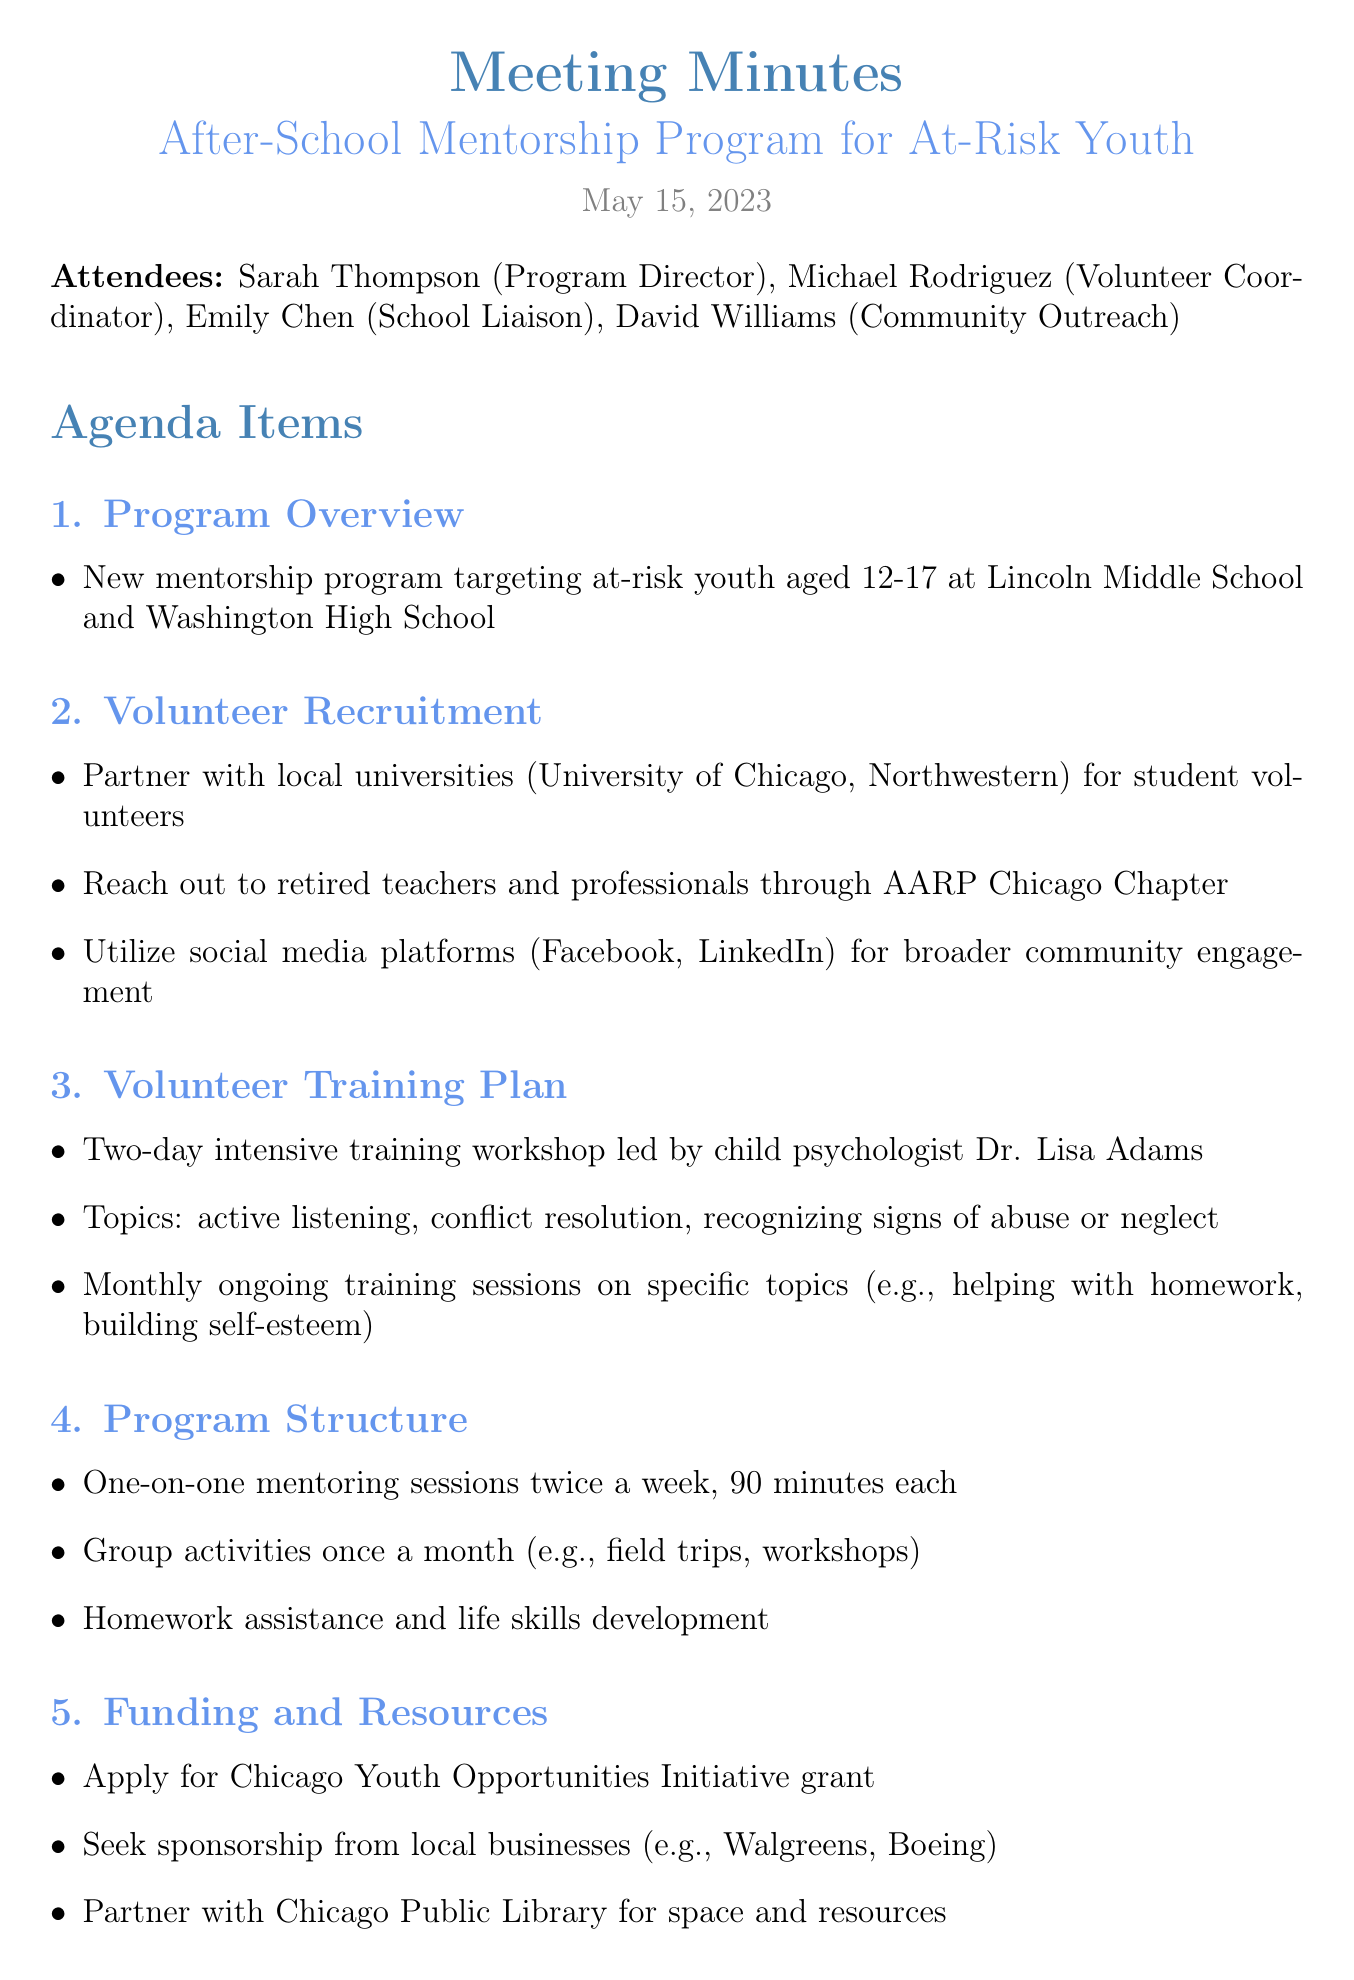what is the date of the meeting? The date of the meeting is stated at the beginning of the document.
Answer: May 15, 2023 who is the Program Director? The Program Director's name is listed among the attendees in the document.
Answer: Sarah Thompson what are the ages targeted by the mentorship program? The age range is included in the program overview section.
Answer: 12-17 how many mentoring sessions are planned each week? The number of sessions per week is specified in the program structure section.
Answer: Twice a week what is the goal for school engagement improvement? The goal is one of the evaluation metrics mentioned in the document.
Answer: 20% who is responsible for creating the volunteer recruitment flyers? The action items list who is responsible for each task.
Answer: Michael what will the volunteer training workshop be led by? The details of the training plan indicate who will lead the workshop.
Answer: child psychologist Dr. Lisa Adams which universities will be partnered with for volunteer recruitment? The volunteer recruitment section mentions specific universities.
Answer: University of Chicago, Northwestern what type of activities are planned once a month? The program structure includes monthly group activities described in the document.
Answer: field trips, workshops 